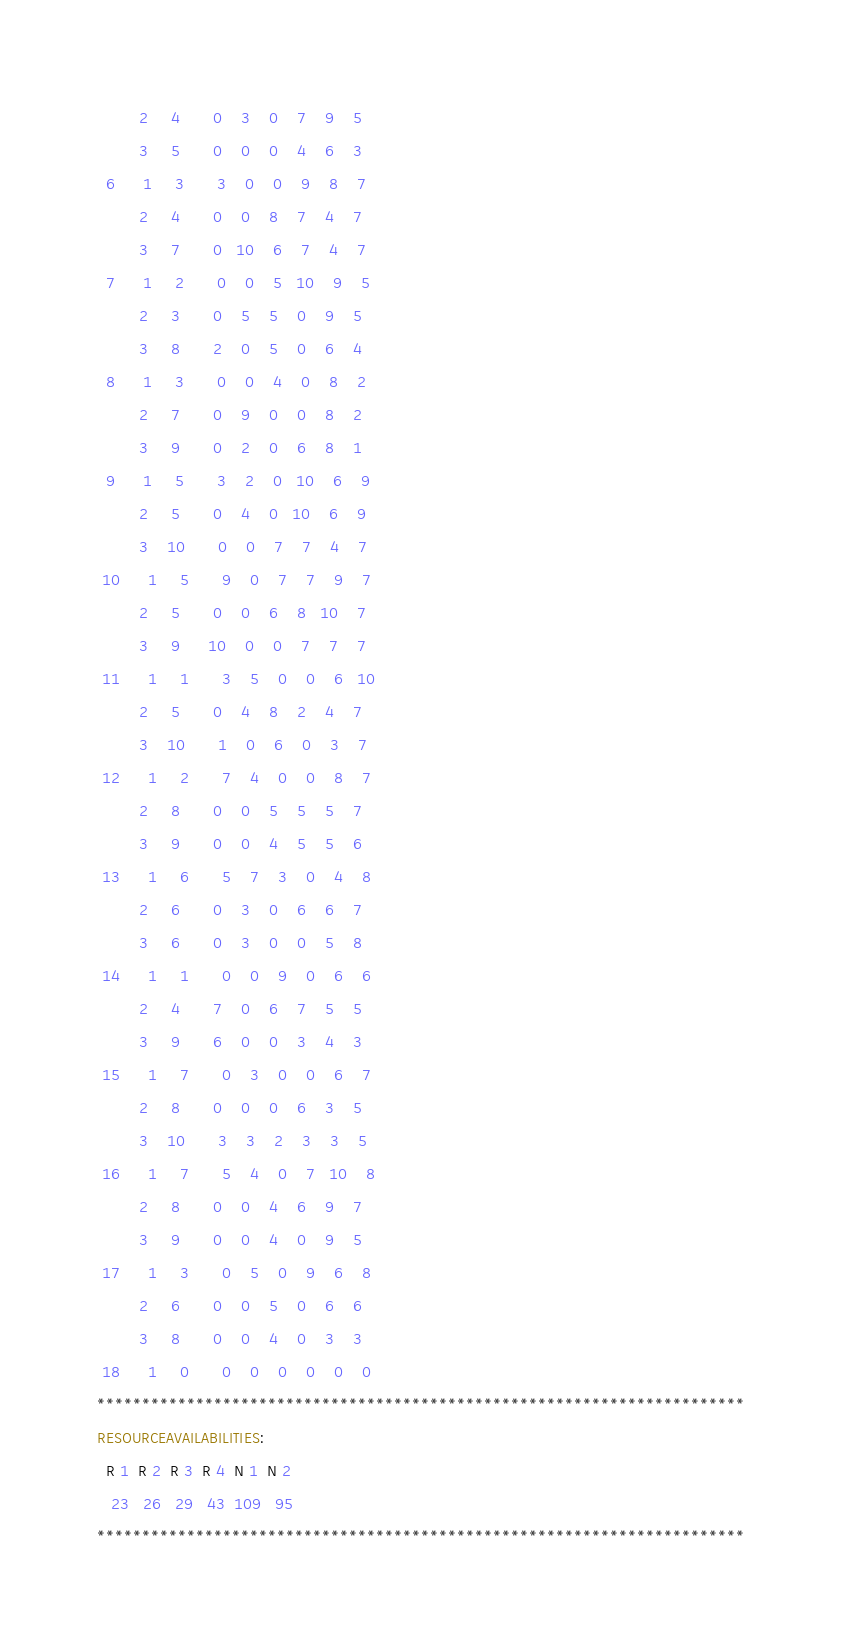<code> <loc_0><loc_0><loc_500><loc_500><_ObjectiveC_>         2     4       0    3    0    7    9    5
         3     5       0    0    0    4    6    3
  6      1     3       3    0    0    9    8    7
         2     4       0    0    8    7    4    7
         3     7       0   10    6    7    4    7
  7      1     2       0    0    5   10    9    5
         2     3       0    5    5    0    9    5
         3     8       2    0    5    0    6    4
  8      1     3       0    0    4    0    8    2
         2     7       0    9    0    0    8    2
         3     9       0    2    0    6    8    1
  9      1     5       3    2    0   10    6    9
         2     5       0    4    0   10    6    9
         3    10       0    0    7    7    4    7
 10      1     5       9    0    7    7    9    7
         2     5       0    0    6    8   10    7
         3     9      10    0    0    7    7    7
 11      1     1       3    5    0    0    6   10
         2     5       0    4    8    2    4    7
         3    10       1    0    6    0    3    7
 12      1     2       7    4    0    0    8    7
         2     8       0    0    5    5    5    7
         3     9       0    0    4    5    5    6
 13      1     6       5    7    3    0    4    8
         2     6       0    3    0    6    6    7
         3     6       0    3    0    0    5    8
 14      1     1       0    0    9    0    6    6
         2     4       7    0    6    7    5    5
         3     9       6    0    0    3    4    3
 15      1     7       0    3    0    0    6    7
         2     8       0    0    0    6    3    5
         3    10       3    3    2    3    3    5
 16      1     7       5    4    0    7   10    8
         2     8       0    0    4    6    9    7
         3     9       0    0    4    0    9    5
 17      1     3       0    5    0    9    6    8
         2     6       0    0    5    0    6    6
         3     8       0    0    4    0    3    3
 18      1     0       0    0    0    0    0    0
************************************************************************
RESOURCEAVAILABILITIES:
  R 1  R 2  R 3  R 4  N 1  N 2
   23   26   29   43  109   95
************************************************************************
</code> 